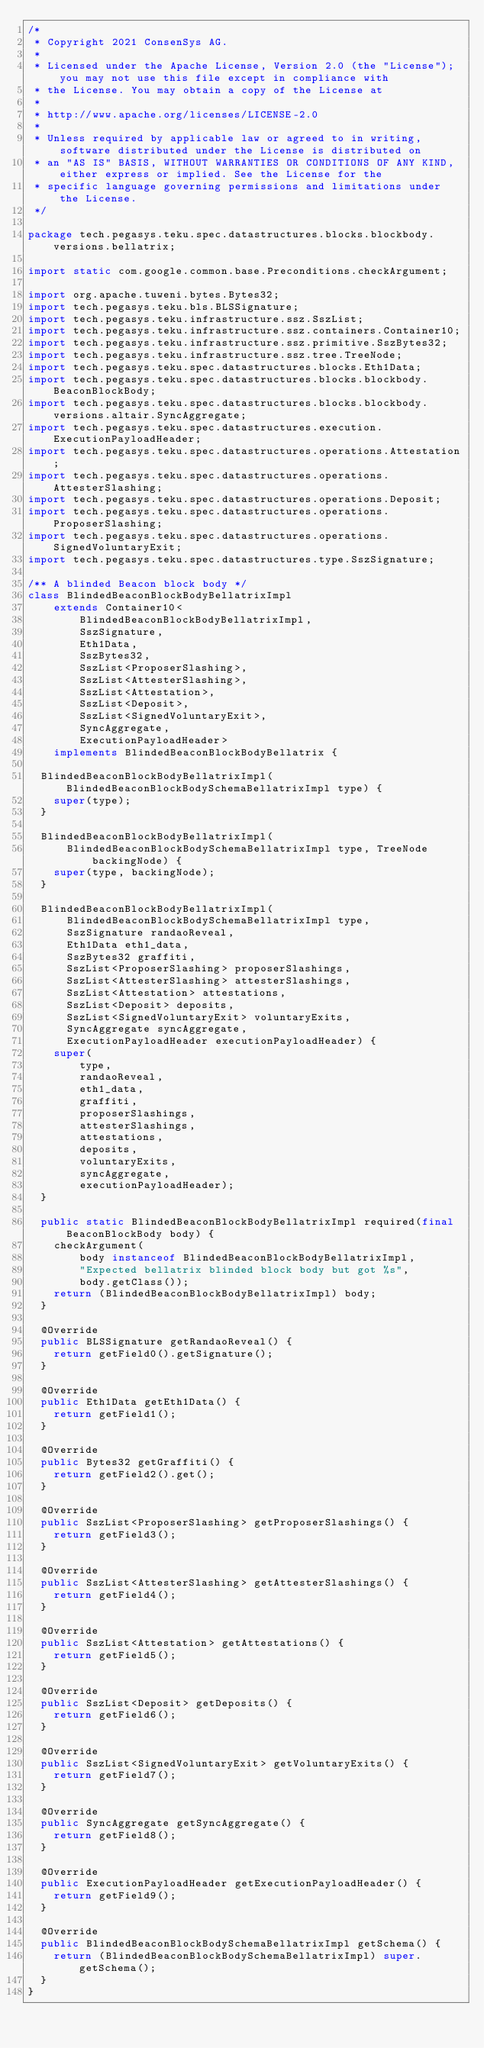Convert code to text. <code><loc_0><loc_0><loc_500><loc_500><_Java_>/*
 * Copyright 2021 ConsenSys AG.
 *
 * Licensed under the Apache License, Version 2.0 (the "License"); you may not use this file except in compliance with
 * the License. You may obtain a copy of the License at
 *
 * http://www.apache.org/licenses/LICENSE-2.0
 *
 * Unless required by applicable law or agreed to in writing, software distributed under the License is distributed on
 * an "AS IS" BASIS, WITHOUT WARRANTIES OR CONDITIONS OF ANY KIND, either express or implied. See the License for the
 * specific language governing permissions and limitations under the License.
 */

package tech.pegasys.teku.spec.datastructures.blocks.blockbody.versions.bellatrix;

import static com.google.common.base.Preconditions.checkArgument;

import org.apache.tuweni.bytes.Bytes32;
import tech.pegasys.teku.bls.BLSSignature;
import tech.pegasys.teku.infrastructure.ssz.SszList;
import tech.pegasys.teku.infrastructure.ssz.containers.Container10;
import tech.pegasys.teku.infrastructure.ssz.primitive.SszBytes32;
import tech.pegasys.teku.infrastructure.ssz.tree.TreeNode;
import tech.pegasys.teku.spec.datastructures.blocks.Eth1Data;
import tech.pegasys.teku.spec.datastructures.blocks.blockbody.BeaconBlockBody;
import tech.pegasys.teku.spec.datastructures.blocks.blockbody.versions.altair.SyncAggregate;
import tech.pegasys.teku.spec.datastructures.execution.ExecutionPayloadHeader;
import tech.pegasys.teku.spec.datastructures.operations.Attestation;
import tech.pegasys.teku.spec.datastructures.operations.AttesterSlashing;
import tech.pegasys.teku.spec.datastructures.operations.Deposit;
import tech.pegasys.teku.spec.datastructures.operations.ProposerSlashing;
import tech.pegasys.teku.spec.datastructures.operations.SignedVoluntaryExit;
import tech.pegasys.teku.spec.datastructures.type.SszSignature;

/** A blinded Beacon block body */
class BlindedBeaconBlockBodyBellatrixImpl
    extends Container10<
        BlindedBeaconBlockBodyBellatrixImpl,
        SszSignature,
        Eth1Data,
        SszBytes32,
        SszList<ProposerSlashing>,
        SszList<AttesterSlashing>,
        SszList<Attestation>,
        SszList<Deposit>,
        SszList<SignedVoluntaryExit>,
        SyncAggregate,
        ExecutionPayloadHeader>
    implements BlindedBeaconBlockBodyBellatrix {

  BlindedBeaconBlockBodyBellatrixImpl(BlindedBeaconBlockBodySchemaBellatrixImpl type) {
    super(type);
  }

  BlindedBeaconBlockBodyBellatrixImpl(
      BlindedBeaconBlockBodySchemaBellatrixImpl type, TreeNode backingNode) {
    super(type, backingNode);
  }

  BlindedBeaconBlockBodyBellatrixImpl(
      BlindedBeaconBlockBodySchemaBellatrixImpl type,
      SszSignature randaoReveal,
      Eth1Data eth1_data,
      SszBytes32 graffiti,
      SszList<ProposerSlashing> proposerSlashings,
      SszList<AttesterSlashing> attesterSlashings,
      SszList<Attestation> attestations,
      SszList<Deposit> deposits,
      SszList<SignedVoluntaryExit> voluntaryExits,
      SyncAggregate syncAggregate,
      ExecutionPayloadHeader executionPayloadHeader) {
    super(
        type,
        randaoReveal,
        eth1_data,
        graffiti,
        proposerSlashings,
        attesterSlashings,
        attestations,
        deposits,
        voluntaryExits,
        syncAggregate,
        executionPayloadHeader);
  }

  public static BlindedBeaconBlockBodyBellatrixImpl required(final BeaconBlockBody body) {
    checkArgument(
        body instanceof BlindedBeaconBlockBodyBellatrixImpl,
        "Expected bellatrix blinded block body but got %s",
        body.getClass());
    return (BlindedBeaconBlockBodyBellatrixImpl) body;
  }

  @Override
  public BLSSignature getRandaoReveal() {
    return getField0().getSignature();
  }

  @Override
  public Eth1Data getEth1Data() {
    return getField1();
  }

  @Override
  public Bytes32 getGraffiti() {
    return getField2().get();
  }

  @Override
  public SszList<ProposerSlashing> getProposerSlashings() {
    return getField3();
  }

  @Override
  public SszList<AttesterSlashing> getAttesterSlashings() {
    return getField4();
  }

  @Override
  public SszList<Attestation> getAttestations() {
    return getField5();
  }

  @Override
  public SszList<Deposit> getDeposits() {
    return getField6();
  }

  @Override
  public SszList<SignedVoluntaryExit> getVoluntaryExits() {
    return getField7();
  }

  @Override
  public SyncAggregate getSyncAggregate() {
    return getField8();
  }

  @Override
  public ExecutionPayloadHeader getExecutionPayloadHeader() {
    return getField9();
  }

  @Override
  public BlindedBeaconBlockBodySchemaBellatrixImpl getSchema() {
    return (BlindedBeaconBlockBodySchemaBellatrixImpl) super.getSchema();
  }
}
</code> 